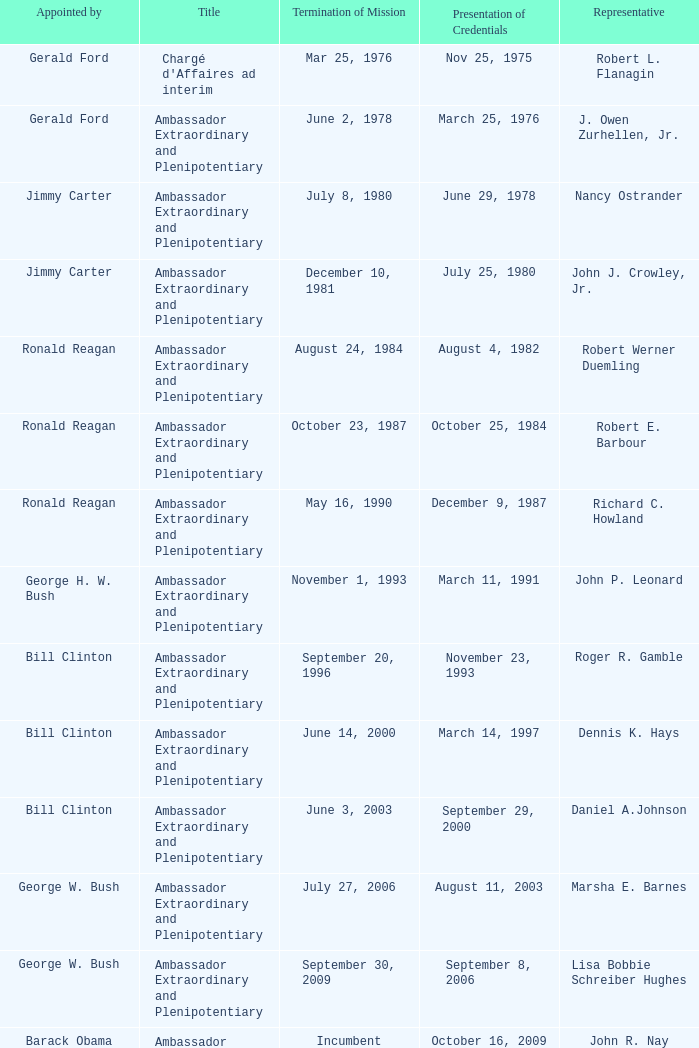Who appointed the representative that had a Presentation of Credentials on March 25, 1976? Gerald Ford. 